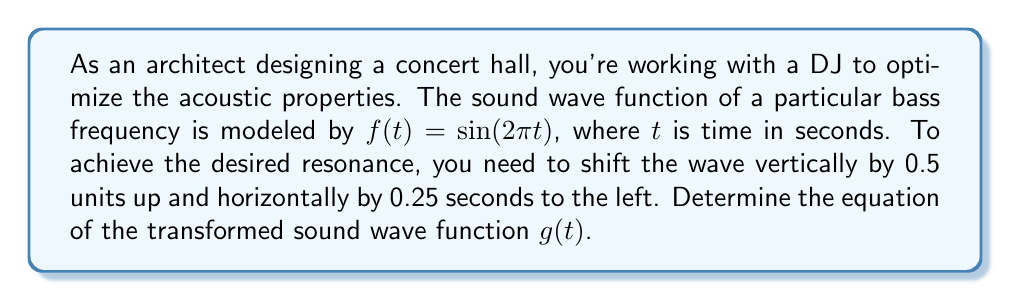Teach me how to tackle this problem. To solve this problem, we need to apply vertical and horizontal transformations to the original function $f(t) = \sin(2\pi t)$.

1. Vertical shift:
   The function needs to be shifted 0.5 units up. This is achieved by adding 0.5 to the function:
   $f_1(t) = \sin(2\pi t) + 0.5$

2. Horizontal shift:
   The function needs to be shifted 0.25 seconds to the left. For a horizontal shift, we modify the input of the function. To shift left, we add inside the parentheses:
   $g(t) = \sin(2\pi(t + 0.25)) + 0.5$

The order of applying these transformations doesn't matter in this case, as they are independent of each other.

To verify:
- The vertical shift of 0.5 is represented by the "+0.5" outside the sine function.
- The horizontal shift of 0.25 to the left is represented by the "+0.25" inside the sine function. Remember, adding inside the parentheses shifts the graph to the left.

Therefore, the transformed sound wave function $g(t)$ incorporates both the vertical and horizontal shifts as required.
Answer: $g(t) = \sin(2\pi(t + 0.25)) + 0.5$ 